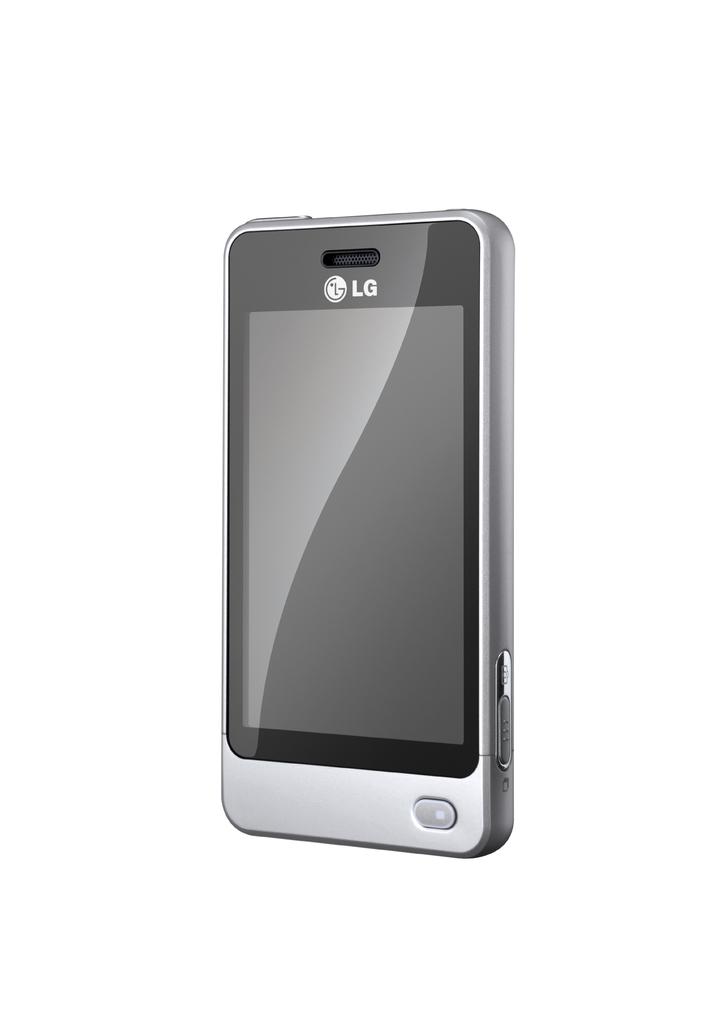What style of phone is this?
Ensure brevity in your answer.  Lg. What kind of phone is that?
Provide a succinct answer. Lg. 